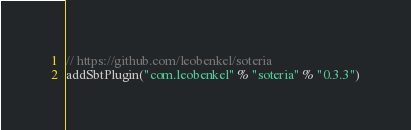<code> <loc_0><loc_0><loc_500><loc_500><_Scala_>// https://github.com/leobenkel/soteria
addSbtPlugin("com.leobenkel" % "soteria" % "0.3.3")
</code> 